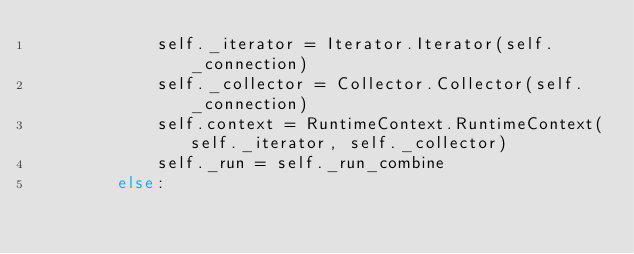<code> <loc_0><loc_0><loc_500><loc_500><_Python_>            self._iterator = Iterator.Iterator(self._connection)
            self._collector = Collector.Collector(self._connection)
            self.context = RuntimeContext.RuntimeContext(self._iterator, self._collector)
            self._run = self._run_combine
        else:</code> 